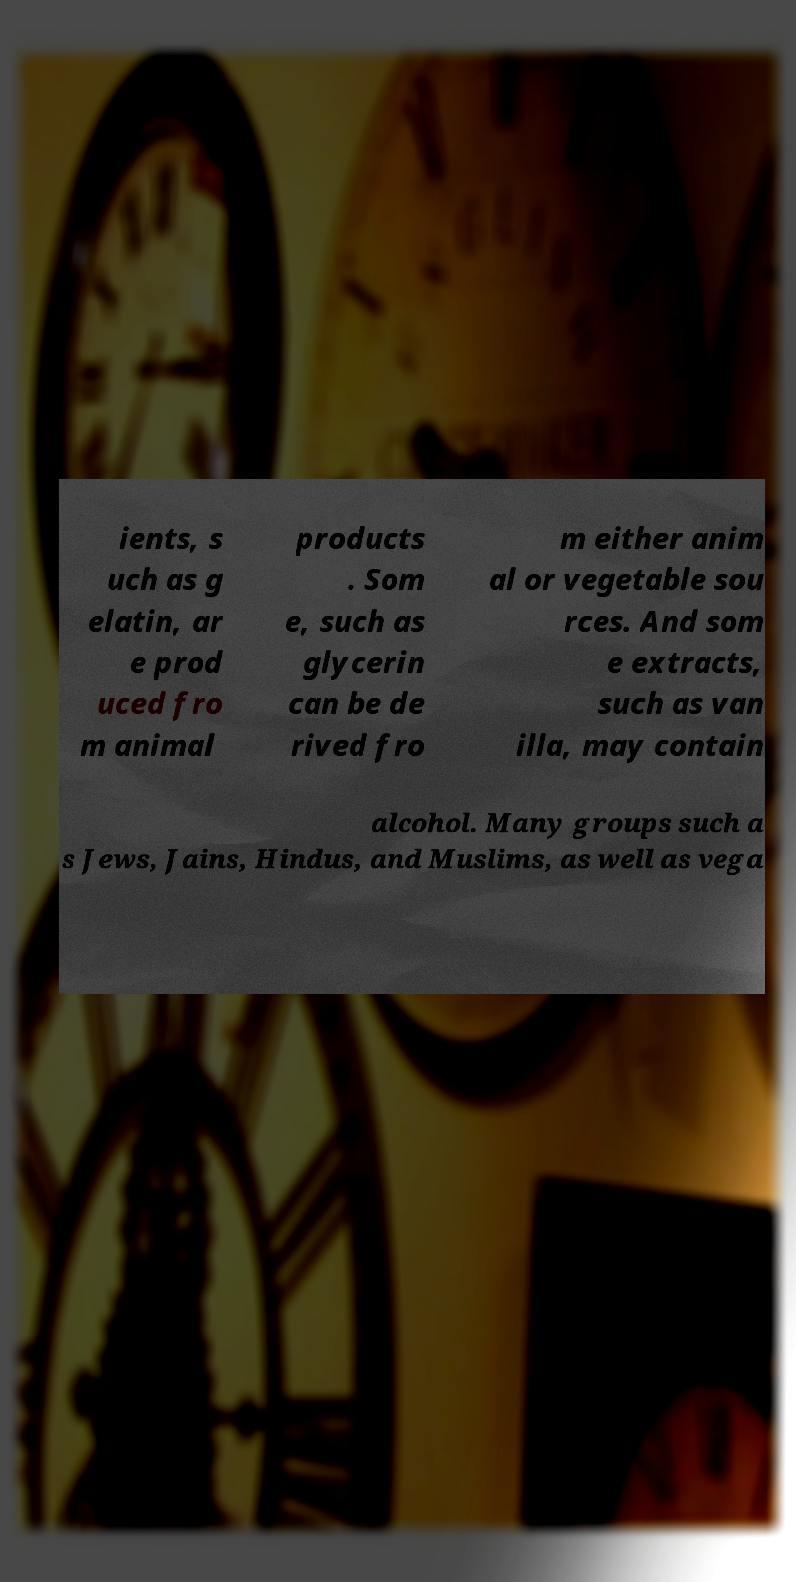Could you extract and type out the text from this image? ients, s uch as g elatin, ar e prod uced fro m animal products . Som e, such as glycerin can be de rived fro m either anim al or vegetable sou rces. And som e extracts, such as van illa, may contain alcohol. Many groups such a s Jews, Jains, Hindus, and Muslims, as well as vega 